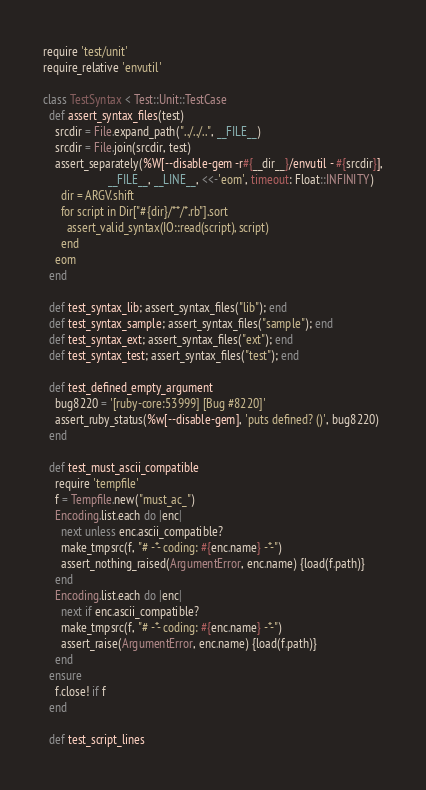<code> <loc_0><loc_0><loc_500><loc_500><_Ruby_>require 'test/unit'
require_relative 'envutil'

class TestSyntax < Test::Unit::TestCase
  def assert_syntax_files(test)
    srcdir = File.expand_path("../../..", __FILE__)
    srcdir = File.join(srcdir, test)
    assert_separately(%W[--disable-gem -r#{__dir__}/envutil - #{srcdir}],
                      __FILE__, __LINE__, <<-'eom', timeout: Float::INFINITY)
      dir = ARGV.shift
      for script in Dir["#{dir}/**/*.rb"].sort
        assert_valid_syntax(IO::read(script), script)
      end
    eom
  end

  def test_syntax_lib; assert_syntax_files("lib"); end
  def test_syntax_sample; assert_syntax_files("sample"); end
  def test_syntax_ext; assert_syntax_files("ext"); end
  def test_syntax_test; assert_syntax_files("test"); end

  def test_defined_empty_argument
    bug8220 = '[ruby-core:53999] [Bug #8220]'
    assert_ruby_status(%w[--disable-gem], 'puts defined? ()', bug8220)
  end

  def test_must_ascii_compatible
    require 'tempfile'
    f = Tempfile.new("must_ac_")
    Encoding.list.each do |enc|
      next unless enc.ascii_compatible?
      make_tmpsrc(f, "# -*- coding: #{enc.name} -*-")
      assert_nothing_raised(ArgumentError, enc.name) {load(f.path)}
    end
    Encoding.list.each do |enc|
      next if enc.ascii_compatible?
      make_tmpsrc(f, "# -*- coding: #{enc.name} -*-")
      assert_raise(ArgumentError, enc.name) {load(f.path)}
    end
  ensure
    f.close! if f
  end

  def test_script_lines</code> 